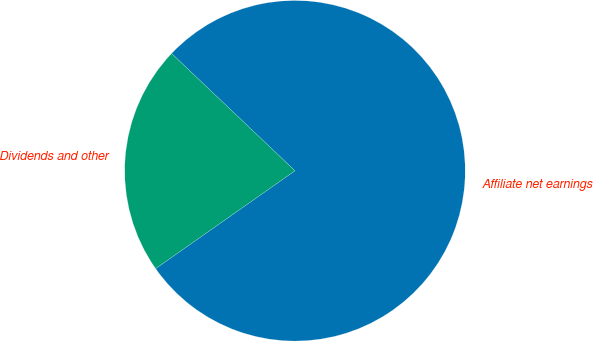<chart> <loc_0><loc_0><loc_500><loc_500><pie_chart><fcel>Affiliate net earnings<fcel>Dividends and other<nl><fcel>78.16%<fcel>21.84%<nl></chart> 